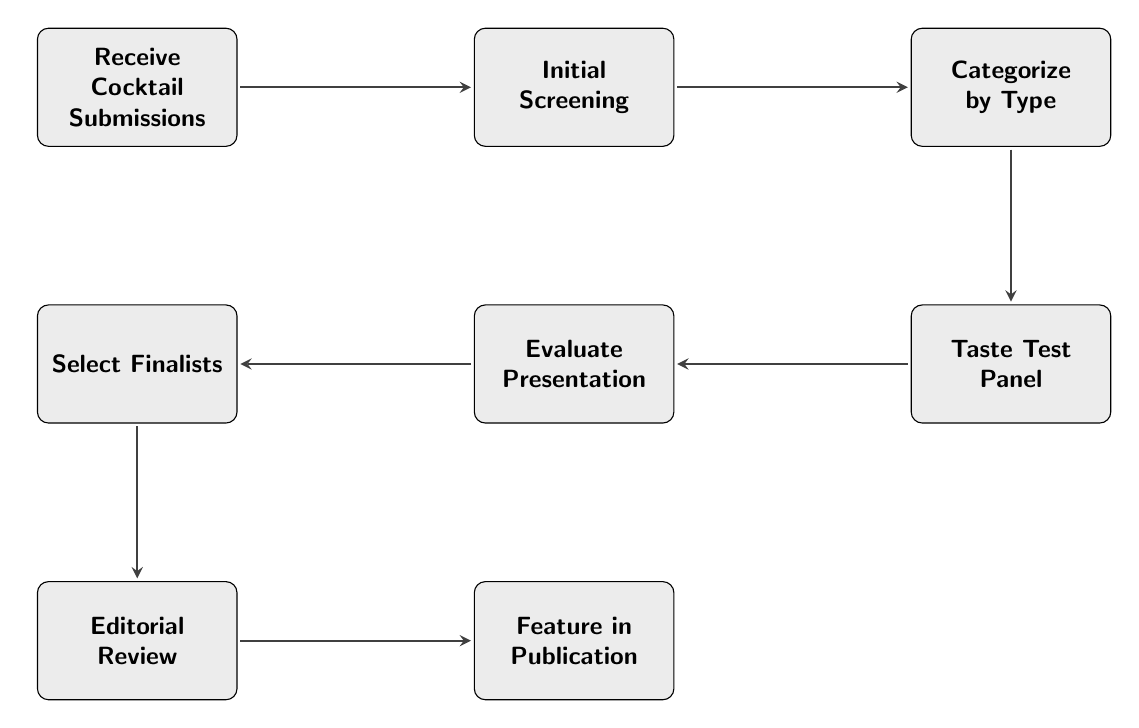What is the first step in the process? The diagram starts with the first node labeled "Receive Cocktail Submissions", which indicates the initial action taken.
Answer: Receive Cocktail Submissions How many nodes are in the flowchart? By counting each distinct process represented in the diagram, there are a total of 8 nodes.
Answer: 8 What follows after "Initial Screening"? The flowchart shows that after "Initial Screening", the next step is "Categorize by Type".
Answer: Categorize by Type Which node assesses the visual appeal of each cocktail? The node "Evaluate Presentation" specifically addresses the assessment of the visual appeal and garnish of each cocktail.
Answer: Evaluate Presentation What is the relationship between "Select Finalists" and "Editorial Review"? According to the flowchart, "Select Finalists" directly leads to "Editorial Review", indicating a sequential process where finalists are considered before final editorial decisions.
Answer: Select Finalists → Editorial Review What is the purpose of the "Taste Test Panel"? The "Taste Test Panel" node is dedicated to forming a group for tasting and evaluating the cocktails, which is a crucial step before final selection.
Answer: Form a panel of editors and bartenders to taste test List the stages before featuring cocktails in the publication. The stages before publication include "Receive Cocktail Submissions," "Initial Screening," "Categorize by Type," "Taste Test Panel," "Evaluate Presentation," and "Select Finalists."
Answer: 6 stages What action signifies that the selection process is completed? When the node "Editorial Review" is reached, it signifies that the selection is finalized, which is the completion of the review process.
Answer: Editorial Review How is the final content structured in the publication? The flowchart shows that after "Editorial Review," the final cocktails are to be designed and laid out for the magazine issue in the "Feature in Publication" node.
Answer: Design and layout the selected cocktails for the magazine issue 